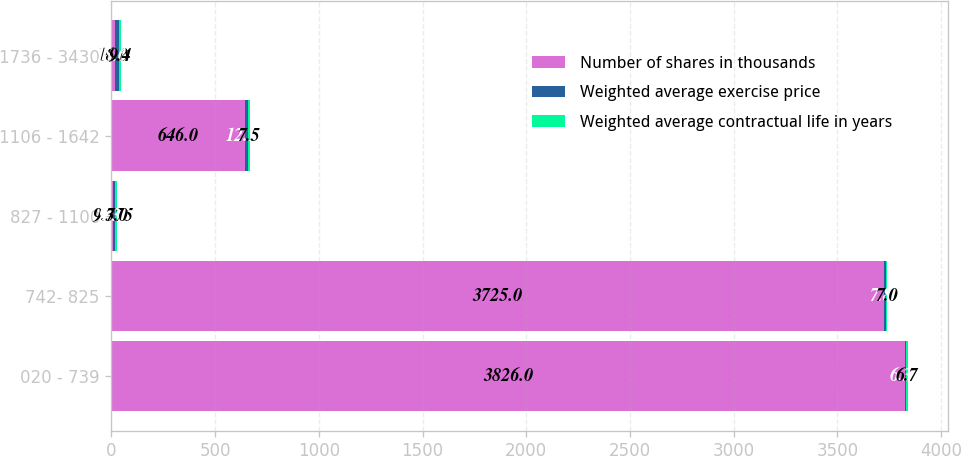<chart> <loc_0><loc_0><loc_500><loc_500><stacked_bar_chart><ecel><fcel>020 - 739<fcel>742- 825<fcel>827 - 1100<fcel>1106 - 1642<fcel>1736 - 3430<nl><fcel>Number of shares in thousands<fcel>3826<fcel>3725<fcel>9.375<fcel>646<fcel>16<nl><fcel>Weighted average exercise price<fcel>6.31<fcel>7.83<fcel>9.35<fcel>12.12<fcel>18.62<nl><fcel>Weighted average contractual life in years<fcel>6.7<fcel>7<fcel>7<fcel>7.5<fcel>9.4<nl></chart> 